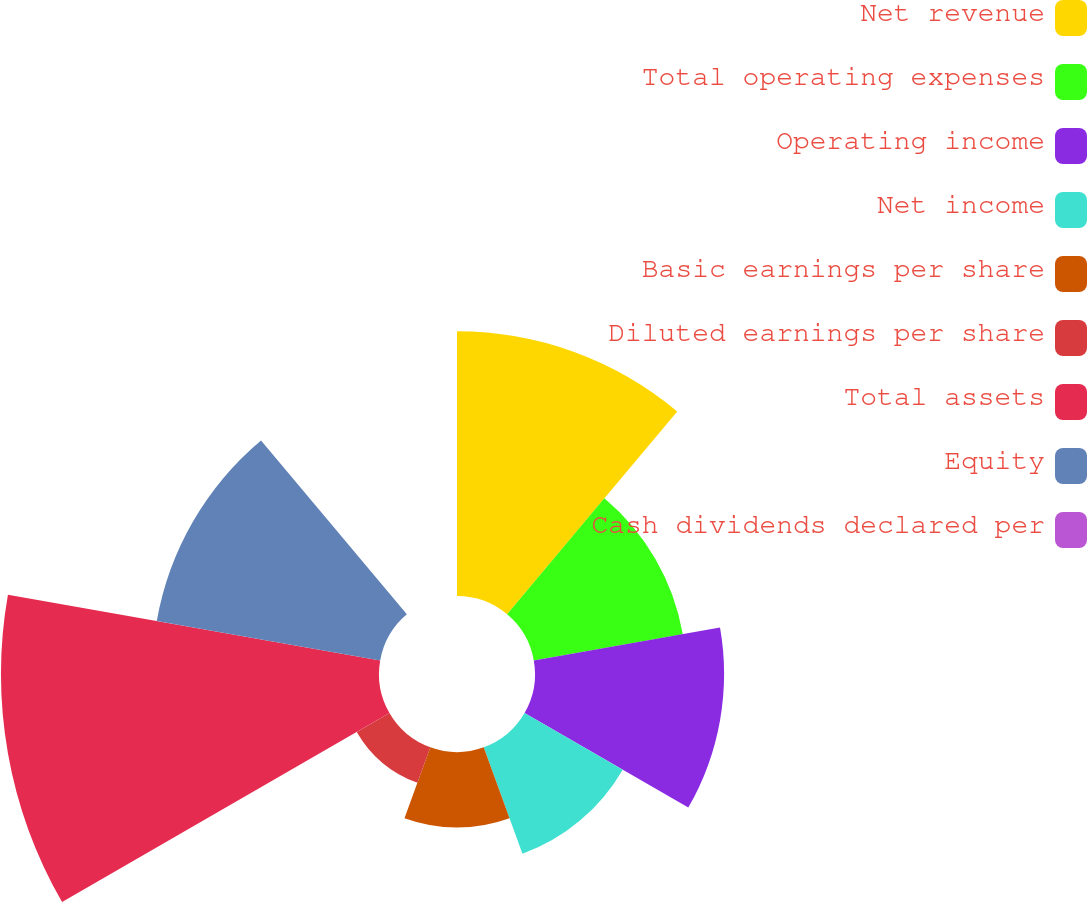<chart> <loc_0><loc_0><loc_500><loc_500><pie_chart><fcel>Net revenue<fcel>Total operating expenses<fcel>Operating income<fcel>Net income<fcel>Basic earnings per share<fcel>Diluted earnings per share<fcel>Total assets<fcel>Equity<fcel>Cash dividends declared per<nl><fcel>18.42%<fcel>10.53%<fcel>13.16%<fcel>7.89%<fcel>5.26%<fcel>2.63%<fcel>26.31%<fcel>15.79%<fcel>0.0%<nl></chart> 